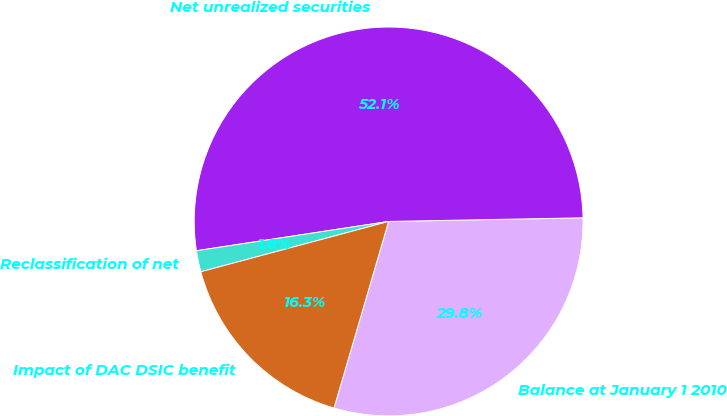<chart> <loc_0><loc_0><loc_500><loc_500><pie_chart><fcel>Balance at January 1 2010<fcel>Net unrealized securities<fcel>Reclassification of net<fcel>Impact of DAC DSIC benefit<nl><fcel>29.83%<fcel>52.11%<fcel>1.76%<fcel>16.3%<nl></chart> 